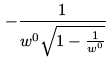<formula> <loc_0><loc_0><loc_500><loc_500>- \frac { 1 } { w ^ { 0 } \sqrt { 1 - \frac { 1 } { w ^ { 0 } } } }</formula> 